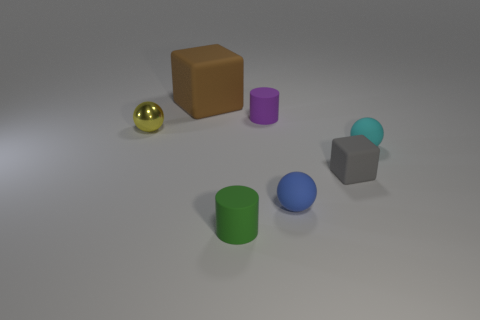What number of things are tiny objects that are in front of the tiny yellow object or matte balls that are in front of the tiny block?
Your answer should be compact. 4. What number of other things are there of the same color as the tiny metallic ball?
Ensure brevity in your answer.  0. There is a tiny rubber object that is behind the small cyan rubber object; does it have the same shape as the gray matte thing?
Ensure brevity in your answer.  No. Is the number of cyan rubber balls left of the purple cylinder less than the number of cyan rubber spheres?
Your response must be concise. Yes. Is there a gray thing that has the same material as the blue object?
Your answer should be very brief. Yes. There is a yellow object that is the same size as the green matte thing; what is its material?
Ensure brevity in your answer.  Metal. Is the number of blue spheres left of the brown block less than the number of cylinders that are behind the tiny green thing?
Provide a succinct answer. Yes. There is a small thing that is behind the cyan matte thing and to the right of the small yellow shiny ball; what shape is it?
Your answer should be very brief. Cylinder. What number of blue rubber objects have the same shape as the tiny gray object?
Make the answer very short. 0. What is the size of the brown block that is the same material as the cyan ball?
Offer a terse response. Large. 